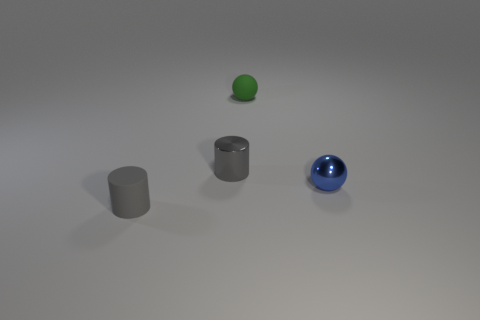Can you infer the texture on the objects? The green sphere appears to have a slightly rough, matte texture which is typical of rubber. The blue sphere has a smooth surface characteristic of polished metal. The cylinders share this metallic sheen and texture, indicating they are also made of a similar material. 